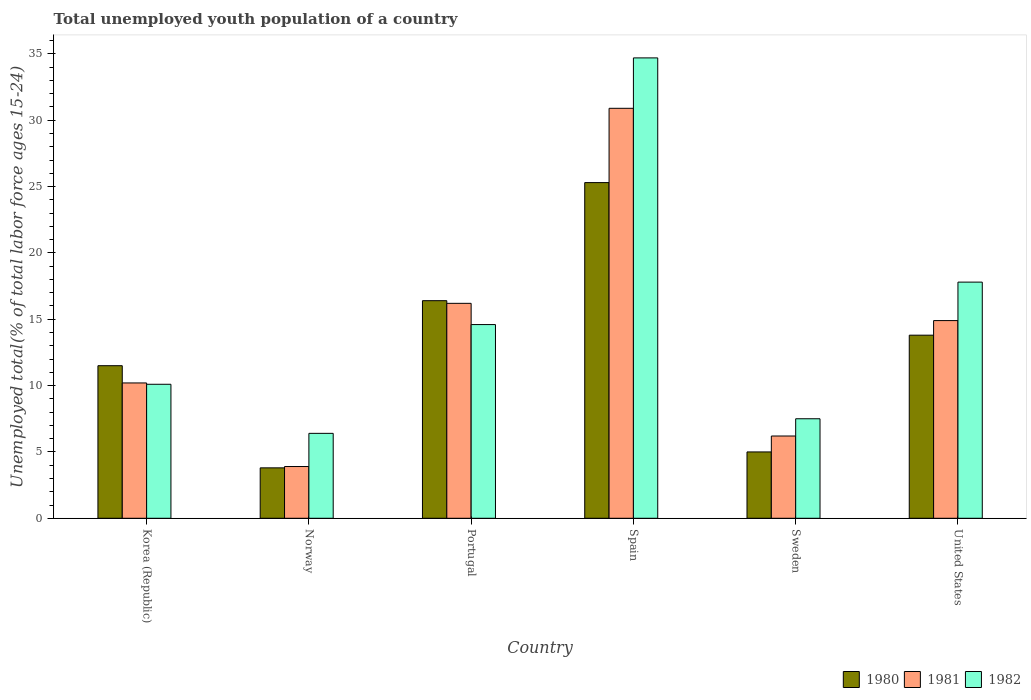How many different coloured bars are there?
Provide a succinct answer. 3. How many groups of bars are there?
Provide a succinct answer. 6. How many bars are there on the 2nd tick from the left?
Ensure brevity in your answer.  3. How many bars are there on the 2nd tick from the right?
Make the answer very short. 3. What is the label of the 1st group of bars from the left?
Keep it short and to the point. Korea (Republic). What is the percentage of total unemployed youth population of a country in 1980 in Korea (Republic)?
Provide a succinct answer. 11.5. Across all countries, what is the maximum percentage of total unemployed youth population of a country in 1980?
Provide a succinct answer. 25.3. Across all countries, what is the minimum percentage of total unemployed youth population of a country in 1981?
Give a very brief answer. 3.9. In which country was the percentage of total unemployed youth population of a country in 1981 maximum?
Make the answer very short. Spain. What is the total percentage of total unemployed youth population of a country in 1980 in the graph?
Your answer should be compact. 75.8. What is the difference between the percentage of total unemployed youth population of a country in 1982 in Portugal and that in United States?
Give a very brief answer. -3.2. What is the difference between the percentage of total unemployed youth population of a country in 1982 in Portugal and the percentage of total unemployed youth population of a country in 1980 in Norway?
Provide a short and direct response. 10.8. What is the average percentage of total unemployed youth population of a country in 1980 per country?
Make the answer very short. 12.63. What is the difference between the percentage of total unemployed youth population of a country of/in 1980 and percentage of total unemployed youth population of a country of/in 1982 in Portugal?
Ensure brevity in your answer.  1.8. In how many countries, is the percentage of total unemployed youth population of a country in 1981 greater than 12 %?
Ensure brevity in your answer.  3. What is the ratio of the percentage of total unemployed youth population of a country in 1980 in Korea (Republic) to that in United States?
Offer a very short reply. 0.83. What is the difference between the highest and the second highest percentage of total unemployed youth population of a country in 1980?
Give a very brief answer. -8.9. What is the difference between the highest and the lowest percentage of total unemployed youth population of a country in 1982?
Ensure brevity in your answer.  28.3. What does the 3rd bar from the left in Norway represents?
Your answer should be very brief. 1982. How many bars are there?
Your response must be concise. 18. How are the legend labels stacked?
Provide a short and direct response. Horizontal. What is the title of the graph?
Provide a short and direct response. Total unemployed youth population of a country. What is the label or title of the Y-axis?
Give a very brief answer. Unemployed total(% of total labor force ages 15-24). What is the Unemployed total(% of total labor force ages 15-24) in 1981 in Korea (Republic)?
Offer a terse response. 10.2. What is the Unemployed total(% of total labor force ages 15-24) in 1982 in Korea (Republic)?
Give a very brief answer. 10.1. What is the Unemployed total(% of total labor force ages 15-24) in 1980 in Norway?
Your answer should be compact. 3.8. What is the Unemployed total(% of total labor force ages 15-24) of 1981 in Norway?
Your answer should be compact. 3.9. What is the Unemployed total(% of total labor force ages 15-24) in 1982 in Norway?
Your answer should be very brief. 6.4. What is the Unemployed total(% of total labor force ages 15-24) of 1980 in Portugal?
Make the answer very short. 16.4. What is the Unemployed total(% of total labor force ages 15-24) in 1981 in Portugal?
Offer a terse response. 16.2. What is the Unemployed total(% of total labor force ages 15-24) of 1982 in Portugal?
Your response must be concise. 14.6. What is the Unemployed total(% of total labor force ages 15-24) in 1980 in Spain?
Give a very brief answer. 25.3. What is the Unemployed total(% of total labor force ages 15-24) of 1981 in Spain?
Your answer should be compact. 30.9. What is the Unemployed total(% of total labor force ages 15-24) in 1982 in Spain?
Give a very brief answer. 34.7. What is the Unemployed total(% of total labor force ages 15-24) in 1980 in Sweden?
Your response must be concise. 5. What is the Unemployed total(% of total labor force ages 15-24) of 1981 in Sweden?
Ensure brevity in your answer.  6.2. What is the Unemployed total(% of total labor force ages 15-24) in 1982 in Sweden?
Keep it short and to the point. 7.5. What is the Unemployed total(% of total labor force ages 15-24) of 1980 in United States?
Provide a succinct answer. 13.8. What is the Unemployed total(% of total labor force ages 15-24) of 1981 in United States?
Your response must be concise. 14.9. What is the Unemployed total(% of total labor force ages 15-24) of 1982 in United States?
Make the answer very short. 17.8. Across all countries, what is the maximum Unemployed total(% of total labor force ages 15-24) in 1980?
Give a very brief answer. 25.3. Across all countries, what is the maximum Unemployed total(% of total labor force ages 15-24) of 1981?
Provide a short and direct response. 30.9. Across all countries, what is the maximum Unemployed total(% of total labor force ages 15-24) of 1982?
Offer a terse response. 34.7. Across all countries, what is the minimum Unemployed total(% of total labor force ages 15-24) of 1980?
Your answer should be very brief. 3.8. Across all countries, what is the minimum Unemployed total(% of total labor force ages 15-24) of 1981?
Offer a very short reply. 3.9. Across all countries, what is the minimum Unemployed total(% of total labor force ages 15-24) in 1982?
Ensure brevity in your answer.  6.4. What is the total Unemployed total(% of total labor force ages 15-24) in 1980 in the graph?
Your answer should be compact. 75.8. What is the total Unemployed total(% of total labor force ages 15-24) of 1981 in the graph?
Provide a short and direct response. 82.3. What is the total Unemployed total(% of total labor force ages 15-24) in 1982 in the graph?
Ensure brevity in your answer.  91.1. What is the difference between the Unemployed total(% of total labor force ages 15-24) in 1980 in Korea (Republic) and that in Norway?
Your answer should be very brief. 7.7. What is the difference between the Unemployed total(% of total labor force ages 15-24) of 1982 in Korea (Republic) and that in Norway?
Offer a very short reply. 3.7. What is the difference between the Unemployed total(% of total labor force ages 15-24) in 1980 in Korea (Republic) and that in Portugal?
Give a very brief answer. -4.9. What is the difference between the Unemployed total(% of total labor force ages 15-24) of 1981 in Korea (Republic) and that in Portugal?
Make the answer very short. -6. What is the difference between the Unemployed total(% of total labor force ages 15-24) of 1982 in Korea (Republic) and that in Portugal?
Provide a succinct answer. -4.5. What is the difference between the Unemployed total(% of total labor force ages 15-24) in 1981 in Korea (Republic) and that in Spain?
Keep it short and to the point. -20.7. What is the difference between the Unemployed total(% of total labor force ages 15-24) of 1982 in Korea (Republic) and that in Spain?
Your answer should be very brief. -24.6. What is the difference between the Unemployed total(% of total labor force ages 15-24) in 1980 in Korea (Republic) and that in Sweden?
Your response must be concise. 6.5. What is the difference between the Unemployed total(% of total labor force ages 15-24) in 1982 in Korea (Republic) and that in Sweden?
Offer a terse response. 2.6. What is the difference between the Unemployed total(% of total labor force ages 15-24) of 1982 in Korea (Republic) and that in United States?
Your answer should be compact. -7.7. What is the difference between the Unemployed total(% of total labor force ages 15-24) in 1980 in Norway and that in Portugal?
Your answer should be very brief. -12.6. What is the difference between the Unemployed total(% of total labor force ages 15-24) in 1981 in Norway and that in Portugal?
Give a very brief answer. -12.3. What is the difference between the Unemployed total(% of total labor force ages 15-24) of 1982 in Norway and that in Portugal?
Offer a terse response. -8.2. What is the difference between the Unemployed total(% of total labor force ages 15-24) in 1980 in Norway and that in Spain?
Give a very brief answer. -21.5. What is the difference between the Unemployed total(% of total labor force ages 15-24) of 1982 in Norway and that in Spain?
Keep it short and to the point. -28.3. What is the difference between the Unemployed total(% of total labor force ages 15-24) of 1980 in Norway and that in Sweden?
Keep it short and to the point. -1.2. What is the difference between the Unemployed total(% of total labor force ages 15-24) of 1981 in Norway and that in Sweden?
Your answer should be compact. -2.3. What is the difference between the Unemployed total(% of total labor force ages 15-24) of 1982 in Norway and that in United States?
Your answer should be compact. -11.4. What is the difference between the Unemployed total(% of total labor force ages 15-24) of 1981 in Portugal and that in Spain?
Offer a terse response. -14.7. What is the difference between the Unemployed total(% of total labor force ages 15-24) in 1982 in Portugal and that in Spain?
Offer a very short reply. -20.1. What is the difference between the Unemployed total(% of total labor force ages 15-24) of 1980 in Portugal and that in Sweden?
Offer a very short reply. 11.4. What is the difference between the Unemployed total(% of total labor force ages 15-24) of 1980 in Portugal and that in United States?
Your response must be concise. 2.6. What is the difference between the Unemployed total(% of total labor force ages 15-24) in 1982 in Portugal and that in United States?
Your answer should be compact. -3.2. What is the difference between the Unemployed total(% of total labor force ages 15-24) of 1980 in Spain and that in Sweden?
Make the answer very short. 20.3. What is the difference between the Unemployed total(% of total labor force ages 15-24) in 1981 in Spain and that in Sweden?
Offer a terse response. 24.7. What is the difference between the Unemployed total(% of total labor force ages 15-24) in 1982 in Spain and that in Sweden?
Your answer should be very brief. 27.2. What is the difference between the Unemployed total(% of total labor force ages 15-24) in 1980 in Sweden and that in United States?
Keep it short and to the point. -8.8. What is the difference between the Unemployed total(% of total labor force ages 15-24) in 1982 in Sweden and that in United States?
Ensure brevity in your answer.  -10.3. What is the difference between the Unemployed total(% of total labor force ages 15-24) of 1980 in Korea (Republic) and the Unemployed total(% of total labor force ages 15-24) of 1981 in Norway?
Your response must be concise. 7.6. What is the difference between the Unemployed total(% of total labor force ages 15-24) of 1980 in Korea (Republic) and the Unemployed total(% of total labor force ages 15-24) of 1982 in Portugal?
Make the answer very short. -3.1. What is the difference between the Unemployed total(% of total labor force ages 15-24) of 1980 in Korea (Republic) and the Unemployed total(% of total labor force ages 15-24) of 1981 in Spain?
Offer a terse response. -19.4. What is the difference between the Unemployed total(% of total labor force ages 15-24) of 1980 in Korea (Republic) and the Unemployed total(% of total labor force ages 15-24) of 1982 in Spain?
Provide a short and direct response. -23.2. What is the difference between the Unemployed total(% of total labor force ages 15-24) in 1981 in Korea (Republic) and the Unemployed total(% of total labor force ages 15-24) in 1982 in Spain?
Provide a succinct answer. -24.5. What is the difference between the Unemployed total(% of total labor force ages 15-24) of 1981 in Korea (Republic) and the Unemployed total(% of total labor force ages 15-24) of 1982 in Sweden?
Your answer should be compact. 2.7. What is the difference between the Unemployed total(% of total labor force ages 15-24) of 1980 in Korea (Republic) and the Unemployed total(% of total labor force ages 15-24) of 1982 in United States?
Keep it short and to the point. -6.3. What is the difference between the Unemployed total(% of total labor force ages 15-24) of 1980 in Norway and the Unemployed total(% of total labor force ages 15-24) of 1982 in Portugal?
Give a very brief answer. -10.8. What is the difference between the Unemployed total(% of total labor force ages 15-24) of 1981 in Norway and the Unemployed total(% of total labor force ages 15-24) of 1982 in Portugal?
Your response must be concise. -10.7. What is the difference between the Unemployed total(% of total labor force ages 15-24) of 1980 in Norway and the Unemployed total(% of total labor force ages 15-24) of 1981 in Spain?
Your response must be concise. -27.1. What is the difference between the Unemployed total(% of total labor force ages 15-24) in 1980 in Norway and the Unemployed total(% of total labor force ages 15-24) in 1982 in Spain?
Provide a short and direct response. -30.9. What is the difference between the Unemployed total(% of total labor force ages 15-24) of 1981 in Norway and the Unemployed total(% of total labor force ages 15-24) of 1982 in Spain?
Provide a succinct answer. -30.8. What is the difference between the Unemployed total(% of total labor force ages 15-24) in 1980 in Norway and the Unemployed total(% of total labor force ages 15-24) in 1982 in Sweden?
Your answer should be compact. -3.7. What is the difference between the Unemployed total(% of total labor force ages 15-24) in 1981 in Norway and the Unemployed total(% of total labor force ages 15-24) in 1982 in Sweden?
Your answer should be very brief. -3.6. What is the difference between the Unemployed total(% of total labor force ages 15-24) of 1980 in Norway and the Unemployed total(% of total labor force ages 15-24) of 1982 in United States?
Your answer should be very brief. -14. What is the difference between the Unemployed total(% of total labor force ages 15-24) of 1980 in Portugal and the Unemployed total(% of total labor force ages 15-24) of 1981 in Spain?
Give a very brief answer. -14.5. What is the difference between the Unemployed total(% of total labor force ages 15-24) in 1980 in Portugal and the Unemployed total(% of total labor force ages 15-24) in 1982 in Spain?
Your answer should be very brief. -18.3. What is the difference between the Unemployed total(% of total labor force ages 15-24) of 1981 in Portugal and the Unemployed total(% of total labor force ages 15-24) of 1982 in Spain?
Your response must be concise. -18.5. What is the difference between the Unemployed total(% of total labor force ages 15-24) of 1981 in Portugal and the Unemployed total(% of total labor force ages 15-24) of 1982 in United States?
Make the answer very short. -1.6. What is the difference between the Unemployed total(% of total labor force ages 15-24) in 1981 in Spain and the Unemployed total(% of total labor force ages 15-24) in 1982 in Sweden?
Your answer should be very brief. 23.4. What is the difference between the Unemployed total(% of total labor force ages 15-24) of 1980 in Sweden and the Unemployed total(% of total labor force ages 15-24) of 1981 in United States?
Provide a succinct answer. -9.9. What is the average Unemployed total(% of total labor force ages 15-24) in 1980 per country?
Provide a succinct answer. 12.63. What is the average Unemployed total(% of total labor force ages 15-24) in 1981 per country?
Provide a succinct answer. 13.72. What is the average Unemployed total(% of total labor force ages 15-24) of 1982 per country?
Offer a terse response. 15.18. What is the difference between the Unemployed total(% of total labor force ages 15-24) of 1980 and Unemployed total(% of total labor force ages 15-24) of 1981 in Korea (Republic)?
Make the answer very short. 1.3. What is the difference between the Unemployed total(% of total labor force ages 15-24) in 1980 and Unemployed total(% of total labor force ages 15-24) in 1982 in Korea (Republic)?
Provide a succinct answer. 1.4. What is the difference between the Unemployed total(% of total labor force ages 15-24) of 1981 and Unemployed total(% of total labor force ages 15-24) of 1982 in Korea (Republic)?
Offer a terse response. 0.1. What is the difference between the Unemployed total(% of total labor force ages 15-24) in 1980 and Unemployed total(% of total labor force ages 15-24) in 1982 in Norway?
Offer a very short reply. -2.6. What is the difference between the Unemployed total(% of total labor force ages 15-24) of 1981 and Unemployed total(% of total labor force ages 15-24) of 1982 in Norway?
Provide a succinct answer. -2.5. What is the difference between the Unemployed total(% of total labor force ages 15-24) in 1980 and Unemployed total(% of total labor force ages 15-24) in 1981 in Portugal?
Ensure brevity in your answer.  0.2. What is the difference between the Unemployed total(% of total labor force ages 15-24) of 1981 and Unemployed total(% of total labor force ages 15-24) of 1982 in Portugal?
Keep it short and to the point. 1.6. What is the difference between the Unemployed total(% of total labor force ages 15-24) of 1980 and Unemployed total(% of total labor force ages 15-24) of 1981 in Spain?
Give a very brief answer. -5.6. What is the difference between the Unemployed total(% of total labor force ages 15-24) of 1980 and Unemployed total(% of total labor force ages 15-24) of 1982 in Spain?
Offer a terse response. -9.4. What is the difference between the Unemployed total(% of total labor force ages 15-24) of 1981 and Unemployed total(% of total labor force ages 15-24) of 1982 in Spain?
Keep it short and to the point. -3.8. What is the difference between the Unemployed total(% of total labor force ages 15-24) in 1980 and Unemployed total(% of total labor force ages 15-24) in 1981 in Sweden?
Ensure brevity in your answer.  -1.2. What is the difference between the Unemployed total(% of total labor force ages 15-24) in 1981 and Unemployed total(% of total labor force ages 15-24) in 1982 in United States?
Make the answer very short. -2.9. What is the ratio of the Unemployed total(% of total labor force ages 15-24) of 1980 in Korea (Republic) to that in Norway?
Make the answer very short. 3.03. What is the ratio of the Unemployed total(% of total labor force ages 15-24) in 1981 in Korea (Republic) to that in Norway?
Ensure brevity in your answer.  2.62. What is the ratio of the Unemployed total(% of total labor force ages 15-24) of 1982 in Korea (Republic) to that in Norway?
Offer a terse response. 1.58. What is the ratio of the Unemployed total(% of total labor force ages 15-24) in 1980 in Korea (Republic) to that in Portugal?
Give a very brief answer. 0.7. What is the ratio of the Unemployed total(% of total labor force ages 15-24) of 1981 in Korea (Republic) to that in Portugal?
Your response must be concise. 0.63. What is the ratio of the Unemployed total(% of total labor force ages 15-24) of 1982 in Korea (Republic) to that in Portugal?
Your answer should be compact. 0.69. What is the ratio of the Unemployed total(% of total labor force ages 15-24) of 1980 in Korea (Republic) to that in Spain?
Make the answer very short. 0.45. What is the ratio of the Unemployed total(% of total labor force ages 15-24) in 1981 in Korea (Republic) to that in Spain?
Provide a succinct answer. 0.33. What is the ratio of the Unemployed total(% of total labor force ages 15-24) of 1982 in Korea (Republic) to that in Spain?
Make the answer very short. 0.29. What is the ratio of the Unemployed total(% of total labor force ages 15-24) of 1981 in Korea (Republic) to that in Sweden?
Your answer should be compact. 1.65. What is the ratio of the Unemployed total(% of total labor force ages 15-24) of 1982 in Korea (Republic) to that in Sweden?
Keep it short and to the point. 1.35. What is the ratio of the Unemployed total(% of total labor force ages 15-24) of 1981 in Korea (Republic) to that in United States?
Your response must be concise. 0.68. What is the ratio of the Unemployed total(% of total labor force ages 15-24) of 1982 in Korea (Republic) to that in United States?
Make the answer very short. 0.57. What is the ratio of the Unemployed total(% of total labor force ages 15-24) in 1980 in Norway to that in Portugal?
Keep it short and to the point. 0.23. What is the ratio of the Unemployed total(% of total labor force ages 15-24) of 1981 in Norway to that in Portugal?
Ensure brevity in your answer.  0.24. What is the ratio of the Unemployed total(% of total labor force ages 15-24) of 1982 in Norway to that in Portugal?
Your response must be concise. 0.44. What is the ratio of the Unemployed total(% of total labor force ages 15-24) of 1980 in Norway to that in Spain?
Provide a short and direct response. 0.15. What is the ratio of the Unemployed total(% of total labor force ages 15-24) in 1981 in Norway to that in Spain?
Offer a very short reply. 0.13. What is the ratio of the Unemployed total(% of total labor force ages 15-24) in 1982 in Norway to that in Spain?
Provide a succinct answer. 0.18. What is the ratio of the Unemployed total(% of total labor force ages 15-24) of 1980 in Norway to that in Sweden?
Your answer should be very brief. 0.76. What is the ratio of the Unemployed total(% of total labor force ages 15-24) of 1981 in Norway to that in Sweden?
Provide a succinct answer. 0.63. What is the ratio of the Unemployed total(% of total labor force ages 15-24) of 1982 in Norway to that in Sweden?
Keep it short and to the point. 0.85. What is the ratio of the Unemployed total(% of total labor force ages 15-24) of 1980 in Norway to that in United States?
Offer a very short reply. 0.28. What is the ratio of the Unemployed total(% of total labor force ages 15-24) in 1981 in Norway to that in United States?
Your answer should be compact. 0.26. What is the ratio of the Unemployed total(% of total labor force ages 15-24) of 1982 in Norway to that in United States?
Give a very brief answer. 0.36. What is the ratio of the Unemployed total(% of total labor force ages 15-24) of 1980 in Portugal to that in Spain?
Offer a terse response. 0.65. What is the ratio of the Unemployed total(% of total labor force ages 15-24) of 1981 in Portugal to that in Spain?
Make the answer very short. 0.52. What is the ratio of the Unemployed total(% of total labor force ages 15-24) in 1982 in Portugal to that in Spain?
Provide a succinct answer. 0.42. What is the ratio of the Unemployed total(% of total labor force ages 15-24) in 1980 in Portugal to that in Sweden?
Your answer should be compact. 3.28. What is the ratio of the Unemployed total(% of total labor force ages 15-24) in 1981 in Portugal to that in Sweden?
Ensure brevity in your answer.  2.61. What is the ratio of the Unemployed total(% of total labor force ages 15-24) in 1982 in Portugal to that in Sweden?
Provide a short and direct response. 1.95. What is the ratio of the Unemployed total(% of total labor force ages 15-24) in 1980 in Portugal to that in United States?
Give a very brief answer. 1.19. What is the ratio of the Unemployed total(% of total labor force ages 15-24) of 1981 in Portugal to that in United States?
Provide a succinct answer. 1.09. What is the ratio of the Unemployed total(% of total labor force ages 15-24) in 1982 in Portugal to that in United States?
Ensure brevity in your answer.  0.82. What is the ratio of the Unemployed total(% of total labor force ages 15-24) of 1980 in Spain to that in Sweden?
Make the answer very short. 5.06. What is the ratio of the Unemployed total(% of total labor force ages 15-24) in 1981 in Spain to that in Sweden?
Keep it short and to the point. 4.98. What is the ratio of the Unemployed total(% of total labor force ages 15-24) in 1982 in Spain to that in Sweden?
Your answer should be very brief. 4.63. What is the ratio of the Unemployed total(% of total labor force ages 15-24) of 1980 in Spain to that in United States?
Make the answer very short. 1.83. What is the ratio of the Unemployed total(% of total labor force ages 15-24) of 1981 in Spain to that in United States?
Provide a succinct answer. 2.07. What is the ratio of the Unemployed total(% of total labor force ages 15-24) of 1982 in Spain to that in United States?
Offer a very short reply. 1.95. What is the ratio of the Unemployed total(% of total labor force ages 15-24) of 1980 in Sweden to that in United States?
Provide a short and direct response. 0.36. What is the ratio of the Unemployed total(% of total labor force ages 15-24) in 1981 in Sweden to that in United States?
Make the answer very short. 0.42. What is the ratio of the Unemployed total(% of total labor force ages 15-24) in 1982 in Sweden to that in United States?
Your answer should be very brief. 0.42. What is the difference between the highest and the second highest Unemployed total(% of total labor force ages 15-24) of 1980?
Offer a very short reply. 8.9. What is the difference between the highest and the second highest Unemployed total(% of total labor force ages 15-24) in 1981?
Your response must be concise. 14.7. What is the difference between the highest and the second highest Unemployed total(% of total labor force ages 15-24) in 1982?
Your response must be concise. 16.9. What is the difference between the highest and the lowest Unemployed total(% of total labor force ages 15-24) of 1980?
Your response must be concise. 21.5. What is the difference between the highest and the lowest Unemployed total(% of total labor force ages 15-24) of 1982?
Keep it short and to the point. 28.3. 